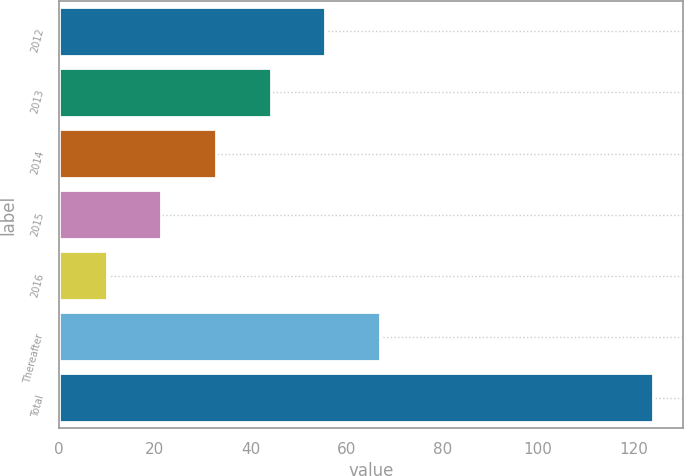<chart> <loc_0><loc_0><loc_500><loc_500><bar_chart><fcel>2012<fcel>2013<fcel>2014<fcel>2015<fcel>2016<fcel>Thereafter<fcel>Total<nl><fcel>55.6<fcel>44.2<fcel>32.8<fcel>21.4<fcel>10<fcel>67<fcel>124<nl></chart> 